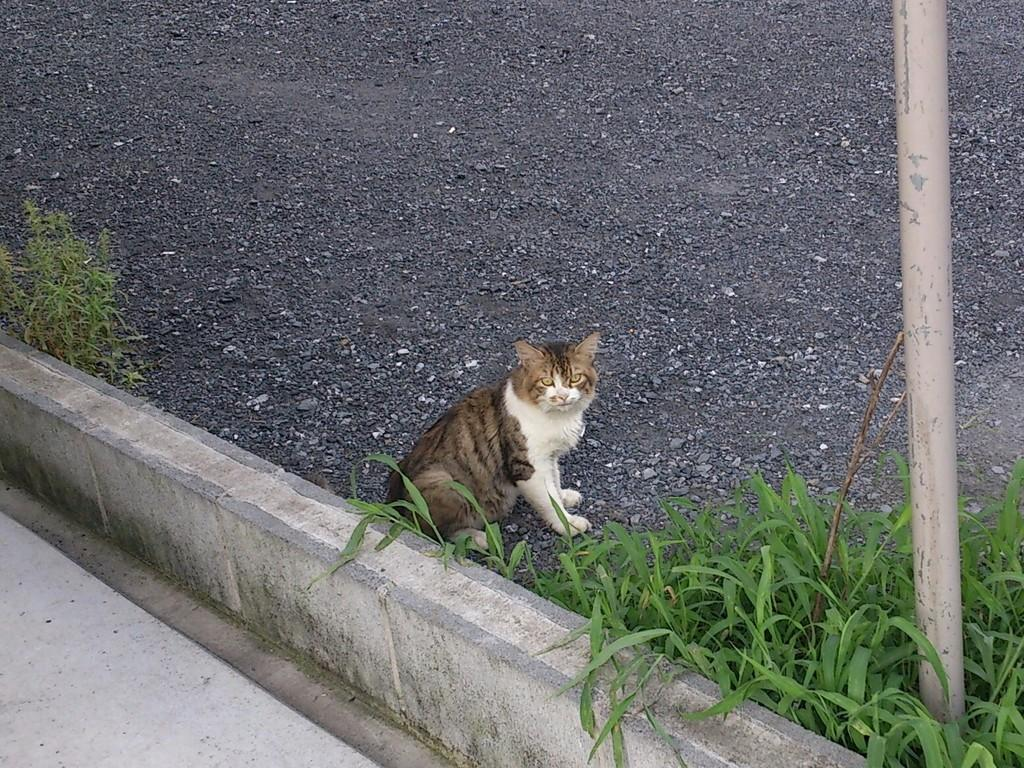What type of animal is in the image? There is a cat in the image. What is behind the cat? There is a fence wall behind the cat. What other elements can be seen in the image? There are small plants and a pole beside the cat, as well as small rocks in the background of the image. What type of cream is being applied to the woman's face in the image? There is no woman or cream present in the image; it features a cat and various other elements. 